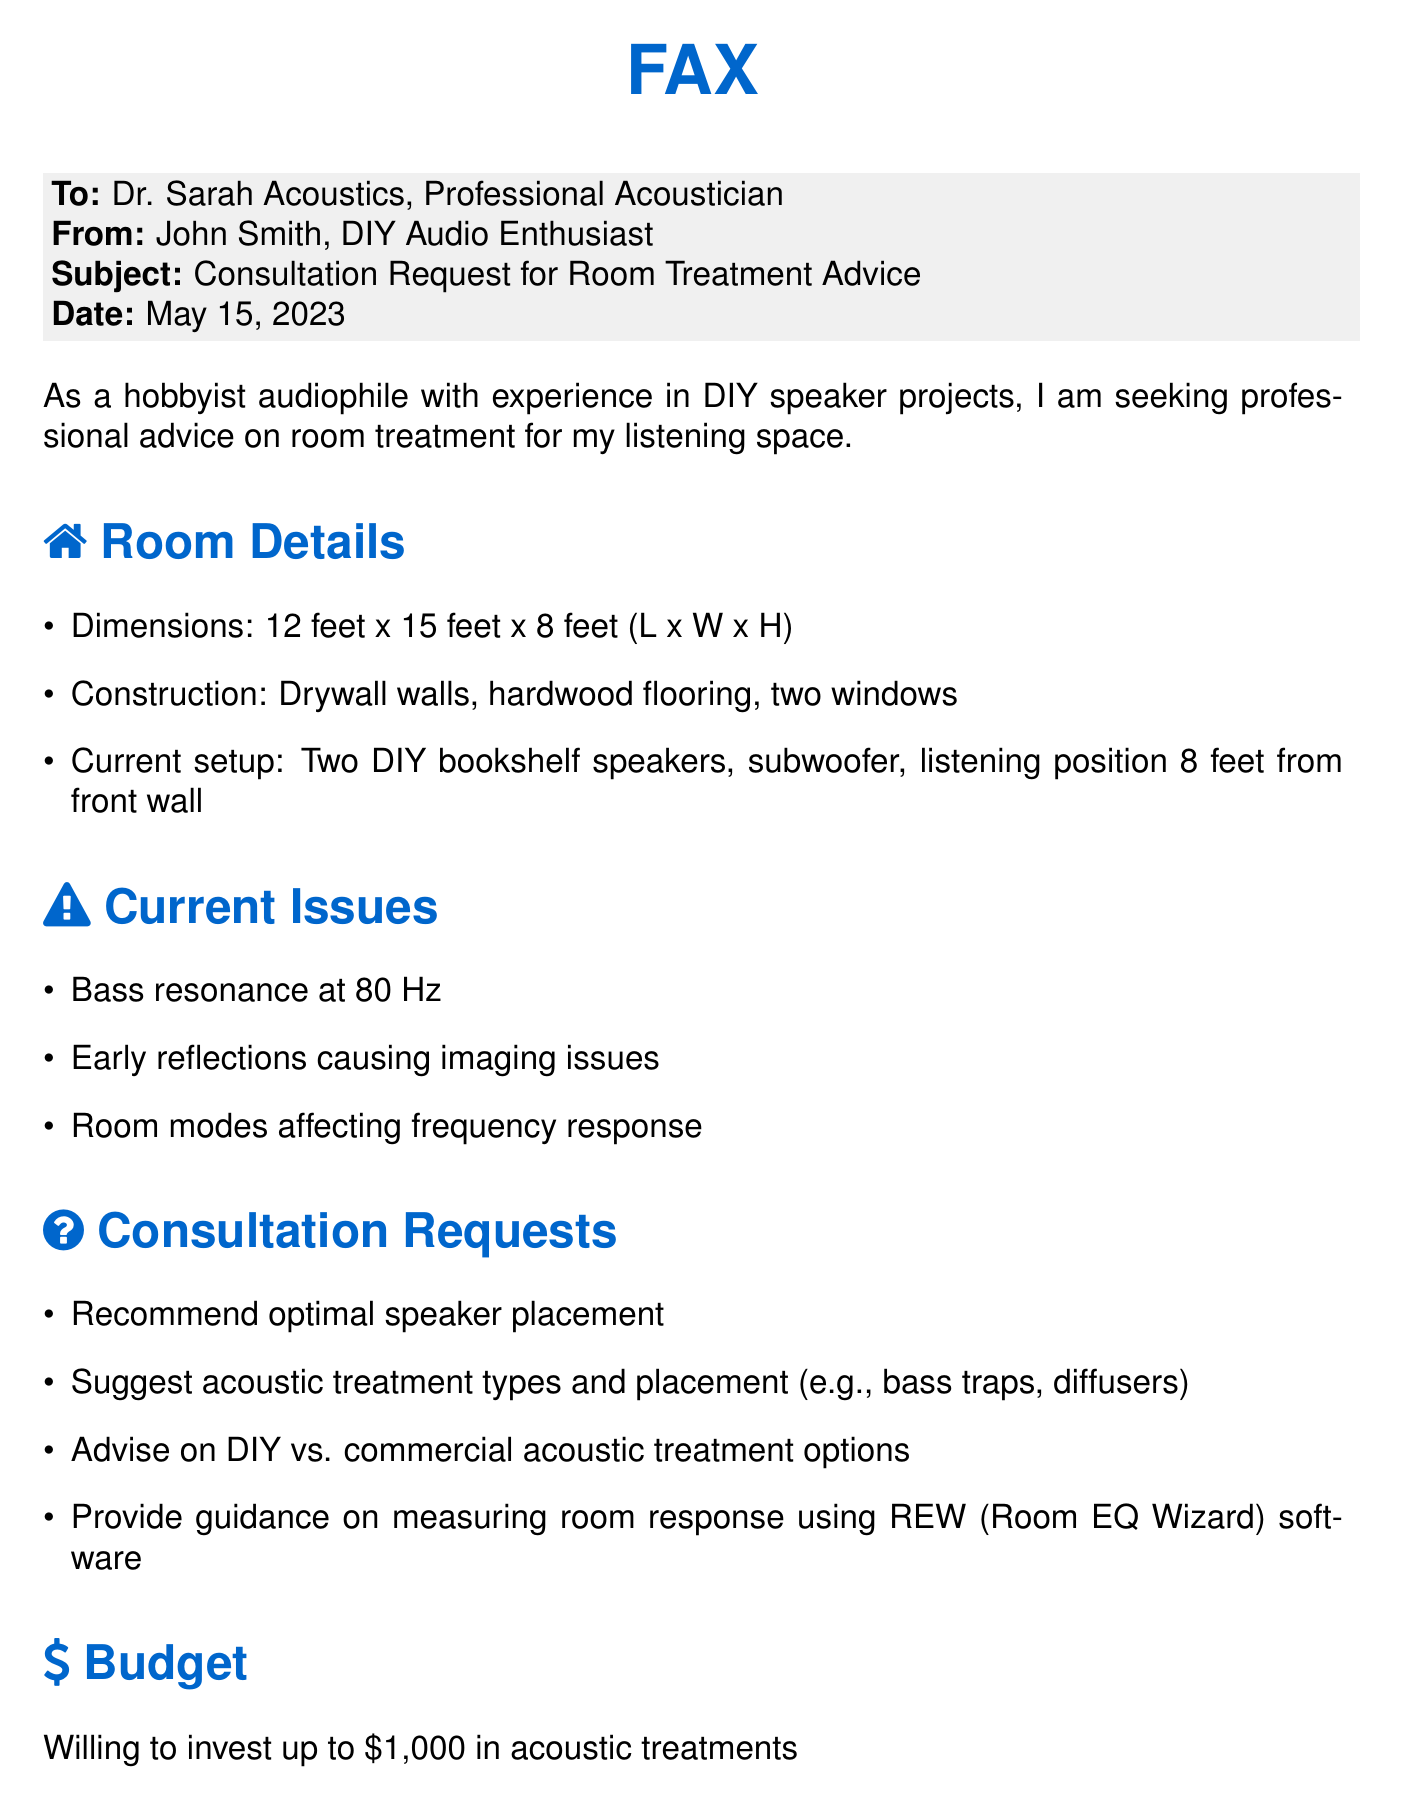What is the recipient's name? The recipient's name is mentioned in the "To" section of the fax.
Answer: Dr. Sarah Acoustics What is the sender's name? The sender's name is mentioned in the "From" section of the fax.
Answer: John Smith What is the subject of the fax? The subject is found in the "Subject" section of the fax.
Answer: Consultation Request for Room Treatment Advice What are the dimensions of the room? The dimensions are listed in the "Room Details" section.
Answer: 12 feet x 15 feet x 8 feet What frequency is causing bass resonance? The issue is specified in the "Current Issues" section.
Answer: 80 Hz What is the listening position distance from the front wall? The distance is detailed in the "Room Details" section.
Answer: 8 feet What is the budget for acoustic treatments? The budget is mentioned in the "Budget" section of the fax.
Answer: $1,000 What types of acoustic treatment options does the sender want advice on? The sender requests advice on treatment options in the "Consultation Requests" section.
Answer: bass traps, diffusers What measurement software does the sender want guidance on? The software is discussed in the "Consultation Requests" section.
Answer: REW (Room EQ Wizard) 